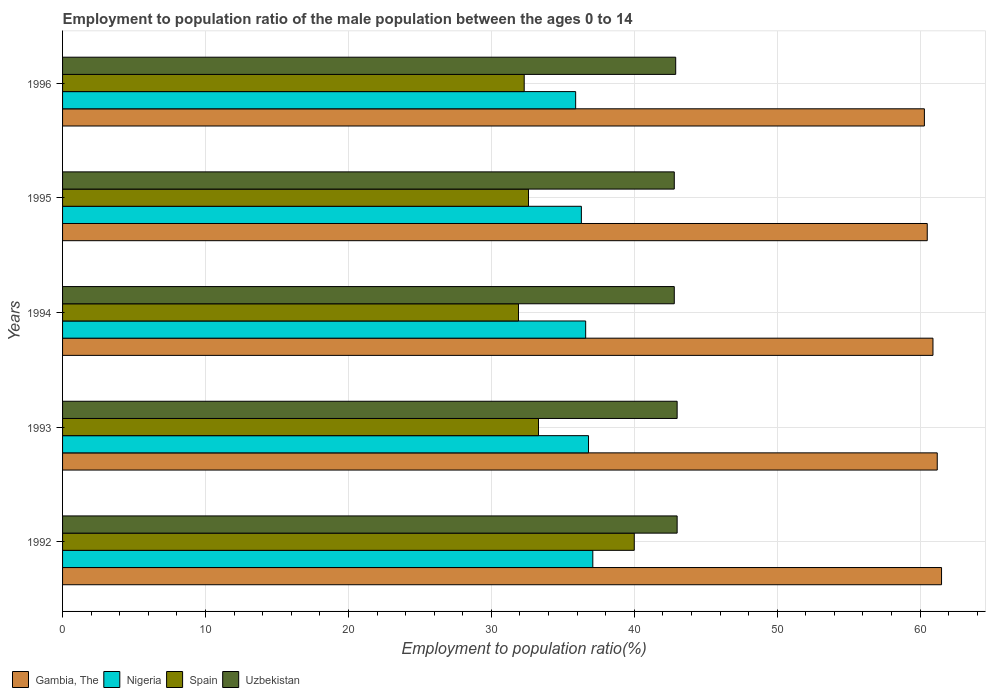How many groups of bars are there?
Provide a short and direct response. 5. Are the number of bars per tick equal to the number of legend labels?
Your answer should be compact. Yes. Are the number of bars on each tick of the Y-axis equal?
Make the answer very short. Yes. How many bars are there on the 5th tick from the top?
Ensure brevity in your answer.  4. What is the label of the 5th group of bars from the top?
Provide a short and direct response. 1992. What is the employment to population ratio in Gambia, The in 1995?
Ensure brevity in your answer.  60.5. Across all years, what is the maximum employment to population ratio in Nigeria?
Ensure brevity in your answer.  37.1. Across all years, what is the minimum employment to population ratio in Uzbekistan?
Offer a very short reply. 42.8. In which year was the employment to population ratio in Nigeria maximum?
Make the answer very short. 1992. In which year was the employment to population ratio in Gambia, The minimum?
Provide a succinct answer. 1996. What is the total employment to population ratio in Gambia, The in the graph?
Keep it short and to the point. 304.4. What is the difference between the employment to population ratio in Uzbekistan in 1993 and that in 1996?
Offer a very short reply. 0.1. What is the difference between the employment to population ratio in Gambia, The in 1994 and the employment to population ratio in Nigeria in 1996?
Ensure brevity in your answer.  25. What is the average employment to population ratio in Spain per year?
Provide a succinct answer. 34.02. In the year 1992, what is the difference between the employment to population ratio in Nigeria and employment to population ratio in Spain?
Make the answer very short. -2.9. In how many years, is the employment to population ratio in Gambia, The greater than 60 %?
Offer a terse response. 5. What is the ratio of the employment to population ratio in Nigeria in 1993 to that in 1995?
Offer a terse response. 1.01. Is the employment to population ratio in Gambia, The in 1992 less than that in 1996?
Offer a very short reply. No. What is the difference between the highest and the lowest employment to population ratio in Spain?
Offer a terse response. 8.1. Is it the case that in every year, the sum of the employment to population ratio in Spain and employment to population ratio in Uzbekistan is greater than the sum of employment to population ratio in Nigeria and employment to population ratio in Gambia, The?
Your answer should be very brief. Yes. What does the 4th bar from the top in 1996 represents?
Your answer should be compact. Gambia, The. What does the 1st bar from the bottom in 1993 represents?
Give a very brief answer. Gambia, The. Are all the bars in the graph horizontal?
Give a very brief answer. Yes. How many years are there in the graph?
Give a very brief answer. 5. What is the difference between two consecutive major ticks on the X-axis?
Keep it short and to the point. 10. Are the values on the major ticks of X-axis written in scientific E-notation?
Your response must be concise. No. Does the graph contain any zero values?
Your answer should be compact. No. Where does the legend appear in the graph?
Make the answer very short. Bottom left. How many legend labels are there?
Keep it short and to the point. 4. What is the title of the graph?
Offer a very short reply. Employment to population ratio of the male population between the ages 0 to 14. What is the label or title of the X-axis?
Ensure brevity in your answer.  Employment to population ratio(%). What is the Employment to population ratio(%) in Gambia, The in 1992?
Make the answer very short. 61.5. What is the Employment to population ratio(%) in Nigeria in 1992?
Provide a succinct answer. 37.1. What is the Employment to population ratio(%) of Gambia, The in 1993?
Provide a short and direct response. 61.2. What is the Employment to population ratio(%) in Nigeria in 1993?
Your response must be concise. 36.8. What is the Employment to population ratio(%) of Spain in 1993?
Give a very brief answer. 33.3. What is the Employment to population ratio(%) of Gambia, The in 1994?
Your response must be concise. 60.9. What is the Employment to population ratio(%) in Nigeria in 1994?
Make the answer very short. 36.6. What is the Employment to population ratio(%) in Spain in 1994?
Give a very brief answer. 31.9. What is the Employment to population ratio(%) in Uzbekistan in 1994?
Ensure brevity in your answer.  42.8. What is the Employment to population ratio(%) of Gambia, The in 1995?
Offer a terse response. 60.5. What is the Employment to population ratio(%) in Nigeria in 1995?
Your response must be concise. 36.3. What is the Employment to population ratio(%) of Spain in 1995?
Your answer should be very brief. 32.6. What is the Employment to population ratio(%) of Uzbekistan in 1995?
Your answer should be compact. 42.8. What is the Employment to population ratio(%) in Gambia, The in 1996?
Your response must be concise. 60.3. What is the Employment to population ratio(%) of Nigeria in 1996?
Ensure brevity in your answer.  35.9. What is the Employment to population ratio(%) in Spain in 1996?
Your response must be concise. 32.3. What is the Employment to population ratio(%) of Uzbekistan in 1996?
Keep it short and to the point. 42.9. Across all years, what is the maximum Employment to population ratio(%) in Gambia, The?
Give a very brief answer. 61.5. Across all years, what is the maximum Employment to population ratio(%) in Nigeria?
Your response must be concise. 37.1. Across all years, what is the maximum Employment to population ratio(%) of Spain?
Offer a terse response. 40. Across all years, what is the maximum Employment to population ratio(%) in Uzbekistan?
Make the answer very short. 43. Across all years, what is the minimum Employment to population ratio(%) of Gambia, The?
Keep it short and to the point. 60.3. Across all years, what is the minimum Employment to population ratio(%) in Nigeria?
Your response must be concise. 35.9. Across all years, what is the minimum Employment to population ratio(%) in Spain?
Ensure brevity in your answer.  31.9. Across all years, what is the minimum Employment to population ratio(%) in Uzbekistan?
Your response must be concise. 42.8. What is the total Employment to population ratio(%) of Gambia, The in the graph?
Offer a very short reply. 304.4. What is the total Employment to population ratio(%) in Nigeria in the graph?
Keep it short and to the point. 182.7. What is the total Employment to population ratio(%) in Spain in the graph?
Keep it short and to the point. 170.1. What is the total Employment to population ratio(%) in Uzbekistan in the graph?
Give a very brief answer. 214.5. What is the difference between the Employment to population ratio(%) in Nigeria in 1992 and that in 1993?
Keep it short and to the point. 0.3. What is the difference between the Employment to population ratio(%) of Uzbekistan in 1992 and that in 1993?
Provide a succinct answer. 0. What is the difference between the Employment to population ratio(%) in Gambia, The in 1992 and that in 1994?
Provide a succinct answer. 0.6. What is the difference between the Employment to population ratio(%) of Nigeria in 1992 and that in 1994?
Give a very brief answer. 0.5. What is the difference between the Employment to population ratio(%) in Gambia, The in 1992 and that in 1995?
Your response must be concise. 1. What is the difference between the Employment to population ratio(%) of Spain in 1992 and that in 1995?
Provide a succinct answer. 7.4. What is the difference between the Employment to population ratio(%) of Uzbekistan in 1992 and that in 1995?
Provide a succinct answer. 0.2. What is the difference between the Employment to population ratio(%) of Gambia, The in 1992 and that in 1996?
Your answer should be compact. 1.2. What is the difference between the Employment to population ratio(%) in Spain in 1992 and that in 1996?
Provide a short and direct response. 7.7. What is the difference between the Employment to population ratio(%) in Nigeria in 1993 and that in 1994?
Make the answer very short. 0.2. What is the difference between the Employment to population ratio(%) in Spain in 1993 and that in 1994?
Keep it short and to the point. 1.4. What is the difference between the Employment to population ratio(%) of Gambia, The in 1993 and that in 1995?
Your answer should be compact. 0.7. What is the difference between the Employment to population ratio(%) of Nigeria in 1993 and that in 1995?
Your answer should be very brief. 0.5. What is the difference between the Employment to population ratio(%) in Uzbekistan in 1993 and that in 1995?
Make the answer very short. 0.2. What is the difference between the Employment to population ratio(%) of Nigeria in 1993 and that in 1996?
Provide a short and direct response. 0.9. What is the difference between the Employment to population ratio(%) in Spain in 1993 and that in 1996?
Offer a terse response. 1. What is the difference between the Employment to population ratio(%) in Uzbekistan in 1993 and that in 1996?
Ensure brevity in your answer.  0.1. What is the difference between the Employment to population ratio(%) in Gambia, The in 1994 and that in 1995?
Provide a succinct answer. 0.4. What is the difference between the Employment to population ratio(%) of Nigeria in 1994 and that in 1995?
Your answer should be very brief. 0.3. What is the difference between the Employment to population ratio(%) of Spain in 1994 and that in 1996?
Make the answer very short. -0.4. What is the difference between the Employment to population ratio(%) in Nigeria in 1995 and that in 1996?
Offer a very short reply. 0.4. What is the difference between the Employment to population ratio(%) in Spain in 1995 and that in 1996?
Your answer should be compact. 0.3. What is the difference between the Employment to population ratio(%) of Gambia, The in 1992 and the Employment to population ratio(%) of Nigeria in 1993?
Your answer should be very brief. 24.7. What is the difference between the Employment to population ratio(%) of Gambia, The in 1992 and the Employment to population ratio(%) of Spain in 1993?
Provide a succinct answer. 28.2. What is the difference between the Employment to population ratio(%) in Spain in 1992 and the Employment to population ratio(%) in Uzbekistan in 1993?
Your answer should be very brief. -3. What is the difference between the Employment to population ratio(%) of Gambia, The in 1992 and the Employment to population ratio(%) of Nigeria in 1994?
Provide a short and direct response. 24.9. What is the difference between the Employment to population ratio(%) of Gambia, The in 1992 and the Employment to population ratio(%) of Spain in 1994?
Make the answer very short. 29.6. What is the difference between the Employment to population ratio(%) of Nigeria in 1992 and the Employment to population ratio(%) of Spain in 1994?
Your response must be concise. 5.2. What is the difference between the Employment to population ratio(%) in Nigeria in 1992 and the Employment to population ratio(%) in Uzbekistan in 1994?
Your response must be concise. -5.7. What is the difference between the Employment to population ratio(%) of Spain in 1992 and the Employment to population ratio(%) of Uzbekistan in 1994?
Give a very brief answer. -2.8. What is the difference between the Employment to population ratio(%) of Gambia, The in 1992 and the Employment to population ratio(%) of Nigeria in 1995?
Provide a short and direct response. 25.2. What is the difference between the Employment to population ratio(%) of Gambia, The in 1992 and the Employment to population ratio(%) of Spain in 1995?
Ensure brevity in your answer.  28.9. What is the difference between the Employment to population ratio(%) in Nigeria in 1992 and the Employment to population ratio(%) in Spain in 1995?
Give a very brief answer. 4.5. What is the difference between the Employment to population ratio(%) in Nigeria in 1992 and the Employment to population ratio(%) in Uzbekistan in 1995?
Provide a succinct answer. -5.7. What is the difference between the Employment to population ratio(%) of Gambia, The in 1992 and the Employment to population ratio(%) of Nigeria in 1996?
Offer a terse response. 25.6. What is the difference between the Employment to population ratio(%) of Gambia, The in 1992 and the Employment to population ratio(%) of Spain in 1996?
Provide a succinct answer. 29.2. What is the difference between the Employment to population ratio(%) in Gambia, The in 1992 and the Employment to population ratio(%) in Uzbekistan in 1996?
Your answer should be compact. 18.6. What is the difference between the Employment to population ratio(%) of Nigeria in 1992 and the Employment to population ratio(%) of Uzbekistan in 1996?
Your answer should be very brief. -5.8. What is the difference between the Employment to population ratio(%) of Gambia, The in 1993 and the Employment to population ratio(%) of Nigeria in 1994?
Give a very brief answer. 24.6. What is the difference between the Employment to population ratio(%) of Gambia, The in 1993 and the Employment to population ratio(%) of Spain in 1994?
Your answer should be compact. 29.3. What is the difference between the Employment to population ratio(%) of Nigeria in 1993 and the Employment to population ratio(%) of Uzbekistan in 1994?
Keep it short and to the point. -6. What is the difference between the Employment to population ratio(%) in Gambia, The in 1993 and the Employment to population ratio(%) in Nigeria in 1995?
Keep it short and to the point. 24.9. What is the difference between the Employment to population ratio(%) of Gambia, The in 1993 and the Employment to population ratio(%) of Spain in 1995?
Offer a terse response. 28.6. What is the difference between the Employment to population ratio(%) of Gambia, The in 1993 and the Employment to population ratio(%) of Uzbekistan in 1995?
Provide a succinct answer. 18.4. What is the difference between the Employment to population ratio(%) in Nigeria in 1993 and the Employment to population ratio(%) in Spain in 1995?
Provide a succinct answer. 4.2. What is the difference between the Employment to population ratio(%) in Spain in 1993 and the Employment to population ratio(%) in Uzbekistan in 1995?
Keep it short and to the point. -9.5. What is the difference between the Employment to population ratio(%) of Gambia, The in 1993 and the Employment to population ratio(%) of Nigeria in 1996?
Ensure brevity in your answer.  25.3. What is the difference between the Employment to population ratio(%) of Gambia, The in 1993 and the Employment to population ratio(%) of Spain in 1996?
Your answer should be compact. 28.9. What is the difference between the Employment to population ratio(%) in Gambia, The in 1993 and the Employment to population ratio(%) in Uzbekistan in 1996?
Your response must be concise. 18.3. What is the difference between the Employment to population ratio(%) of Nigeria in 1993 and the Employment to population ratio(%) of Uzbekistan in 1996?
Offer a terse response. -6.1. What is the difference between the Employment to population ratio(%) in Spain in 1993 and the Employment to population ratio(%) in Uzbekistan in 1996?
Offer a very short reply. -9.6. What is the difference between the Employment to population ratio(%) in Gambia, The in 1994 and the Employment to population ratio(%) in Nigeria in 1995?
Offer a terse response. 24.6. What is the difference between the Employment to population ratio(%) in Gambia, The in 1994 and the Employment to population ratio(%) in Spain in 1995?
Offer a terse response. 28.3. What is the difference between the Employment to population ratio(%) in Gambia, The in 1994 and the Employment to population ratio(%) in Uzbekistan in 1995?
Ensure brevity in your answer.  18.1. What is the difference between the Employment to population ratio(%) in Nigeria in 1994 and the Employment to population ratio(%) in Uzbekistan in 1995?
Offer a very short reply. -6.2. What is the difference between the Employment to population ratio(%) of Gambia, The in 1994 and the Employment to population ratio(%) of Nigeria in 1996?
Your answer should be compact. 25. What is the difference between the Employment to population ratio(%) in Gambia, The in 1994 and the Employment to population ratio(%) in Spain in 1996?
Your response must be concise. 28.6. What is the difference between the Employment to population ratio(%) in Gambia, The in 1995 and the Employment to population ratio(%) in Nigeria in 1996?
Ensure brevity in your answer.  24.6. What is the difference between the Employment to population ratio(%) of Gambia, The in 1995 and the Employment to population ratio(%) of Spain in 1996?
Ensure brevity in your answer.  28.2. What is the difference between the Employment to population ratio(%) in Gambia, The in 1995 and the Employment to population ratio(%) in Uzbekistan in 1996?
Your response must be concise. 17.6. What is the difference between the Employment to population ratio(%) of Spain in 1995 and the Employment to population ratio(%) of Uzbekistan in 1996?
Offer a very short reply. -10.3. What is the average Employment to population ratio(%) in Gambia, The per year?
Make the answer very short. 60.88. What is the average Employment to population ratio(%) of Nigeria per year?
Make the answer very short. 36.54. What is the average Employment to population ratio(%) of Spain per year?
Provide a succinct answer. 34.02. What is the average Employment to population ratio(%) in Uzbekistan per year?
Provide a short and direct response. 42.9. In the year 1992, what is the difference between the Employment to population ratio(%) in Gambia, The and Employment to population ratio(%) in Nigeria?
Ensure brevity in your answer.  24.4. In the year 1992, what is the difference between the Employment to population ratio(%) in Gambia, The and Employment to population ratio(%) in Spain?
Your answer should be compact. 21.5. In the year 1992, what is the difference between the Employment to population ratio(%) in Gambia, The and Employment to population ratio(%) in Uzbekistan?
Your answer should be very brief. 18.5. In the year 1992, what is the difference between the Employment to population ratio(%) in Nigeria and Employment to population ratio(%) in Uzbekistan?
Provide a succinct answer. -5.9. In the year 1992, what is the difference between the Employment to population ratio(%) of Spain and Employment to population ratio(%) of Uzbekistan?
Keep it short and to the point. -3. In the year 1993, what is the difference between the Employment to population ratio(%) in Gambia, The and Employment to population ratio(%) in Nigeria?
Make the answer very short. 24.4. In the year 1993, what is the difference between the Employment to population ratio(%) of Gambia, The and Employment to population ratio(%) of Spain?
Your answer should be very brief. 27.9. In the year 1994, what is the difference between the Employment to population ratio(%) of Gambia, The and Employment to population ratio(%) of Nigeria?
Provide a short and direct response. 24.3. In the year 1994, what is the difference between the Employment to population ratio(%) in Gambia, The and Employment to population ratio(%) in Spain?
Offer a very short reply. 29. In the year 1994, what is the difference between the Employment to population ratio(%) of Nigeria and Employment to population ratio(%) of Uzbekistan?
Provide a short and direct response. -6.2. In the year 1994, what is the difference between the Employment to population ratio(%) of Spain and Employment to population ratio(%) of Uzbekistan?
Your response must be concise. -10.9. In the year 1995, what is the difference between the Employment to population ratio(%) in Gambia, The and Employment to population ratio(%) in Nigeria?
Keep it short and to the point. 24.2. In the year 1995, what is the difference between the Employment to population ratio(%) of Gambia, The and Employment to population ratio(%) of Spain?
Ensure brevity in your answer.  27.9. In the year 1995, what is the difference between the Employment to population ratio(%) of Gambia, The and Employment to population ratio(%) of Uzbekistan?
Your answer should be compact. 17.7. In the year 1995, what is the difference between the Employment to population ratio(%) in Nigeria and Employment to population ratio(%) in Uzbekistan?
Make the answer very short. -6.5. In the year 1996, what is the difference between the Employment to population ratio(%) in Gambia, The and Employment to population ratio(%) in Nigeria?
Keep it short and to the point. 24.4. In the year 1996, what is the difference between the Employment to population ratio(%) of Gambia, The and Employment to population ratio(%) of Spain?
Offer a very short reply. 28. In the year 1996, what is the difference between the Employment to population ratio(%) in Gambia, The and Employment to population ratio(%) in Uzbekistan?
Your response must be concise. 17.4. What is the ratio of the Employment to population ratio(%) of Nigeria in 1992 to that in 1993?
Offer a terse response. 1.01. What is the ratio of the Employment to population ratio(%) of Spain in 1992 to that in 1993?
Provide a succinct answer. 1.2. What is the ratio of the Employment to population ratio(%) in Uzbekistan in 1992 to that in 1993?
Ensure brevity in your answer.  1. What is the ratio of the Employment to population ratio(%) of Gambia, The in 1992 to that in 1994?
Make the answer very short. 1.01. What is the ratio of the Employment to population ratio(%) of Nigeria in 1992 to that in 1994?
Offer a very short reply. 1.01. What is the ratio of the Employment to population ratio(%) of Spain in 1992 to that in 1994?
Your response must be concise. 1.25. What is the ratio of the Employment to population ratio(%) of Uzbekistan in 1992 to that in 1994?
Ensure brevity in your answer.  1. What is the ratio of the Employment to population ratio(%) in Gambia, The in 1992 to that in 1995?
Make the answer very short. 1.02. What is the ratio of the Employment to population ratio(%) in Nigeria in 1992 to that in 1995?
Give a very brief answer. 1.02. What is the ratio of the Employment to population ratio(%) in Spain in 1992 to that in 1995?
Make the answer very short. 1.23. What is the ratio of the Employment to population ratio(%) in Gambia, The in 1992 to that in 1996?
Your response must be concise. 1.02. What is the ratio of the Employment to population ratio(%) in Nigeria in 1992 to that in 1996?
Offer a very short reply. 1.03. What is the ratio of the Employment to population ratio(%) of Spain in 1992 to that in 1996?
Ensure brevity in your answer.  1.24. What is the ratio of the Employment to population ratio(%) of Uzbekistan in 1992 to that in 1996?
Give a very brief answer. 1. What is the ratio of the Employment to population ratio(%) in Nigeria in 1993 to that in 1994?
Your response must be concise. 1.01. What is the ratio of the Employment to population ratio(%) in Spain in 1993 to that in 1994?
Offer a very short reply. 1.04. What is the ratio of the Employment to population ratio(%) of Gambia, The in 1993 to that in 1995?
Your response must be concise. 1.01. What is the ratio of the Employment to population ratio(%) of Nigeria in 1993 to that in 1995?
Make the answer very short. 1.01. What is the ratio of the Employment to population ratio(%) in Spain in 1993 to that in 1995?
Give a very brief answer. 1.02. What is the ratio of the Employment to population ratio(%) in Uzbekistan in 1993 to that in 1995?
Give a very brief answer. 1. What is the ratio of the Employment to population ratio(%) of Gambia, The in 1993 to that in 1996?
Your answer should be very brief. 1.01. What is the ratio of the Employment to population ratio(%) in Nigeria in 1993 to that in 1996?
Make the answer very short. 1.03. What is the ratio of the Employment to population ratio(%) of Spain in 1993 to that in 1996?
Offer a terse response. 1.03. What is the ratio of the Employment to population ratio(%) of Uzbekistan in 1993 to that in 1996?
Offer a terse response. 1. What is the ratio of the Employment to population ratio(%) in Gambia, The in 1994 to that in 1995?
Make the answer very short. 1.01. What is the ratio of the Employment to population ratio(%) in Nigeria in 1994 to that in 1995?
Provide a short and direct response. 1.01. What is the ratio of the Employment to population ratio(%) in Spain in 1994 to that in 1995?
Your response must be concise. 0.98. What is the ratio of the Employment to population ratio(%) of Uzbekistan in 1994 to that in 1995?
Keep it short and to the point. 1. What is the ratio of the Employment to population ratio(%) in Gambia, The in 1994 to that in 1996?
Offer a very short reply. 1.01. What is the ratio of the Employment to population ratio(%) in Nigeria in 1994 to that in 1996?
Make the answer very short. 1.02. What is the ratio of the Employment to population ratio(%) of Spain in 1994 to that in 1996?
Ensure brevity in your answer.  0.99. What is the ratio of the Employment to population ratio(%) of Uzbekistan in 1994 to that in 1996?
Offer a very short reply. 1. What is the ratio of the Employment to population ratio(%) in Gambia, The in 1995 to that in 1996?
Provide a succinct answer. 1. What is the ratio of the Employment to population ratio(%) of Nigeria in 1995 to that in 1996?
Ensure brevity in your answer.  1.01. What is the ratio of the Employment to population ratio(%) of Spain in 1995 to that in 1996?
Offer a very short reply. 1.01. What is the ratio of the Employment to population ratio(%) in Uzbekistan in 1995 to that in 1996?
Give a very brief answer. 1. What is the difference between the highest and the second highest Employment to population ratio(%) in Nigeria?
Give a very brief answer. 0.3. What is the difference between the highest and the lowest Employment to population ratio(%) in Gambia, The?
Ensure brevity in your answer.  1.2. 